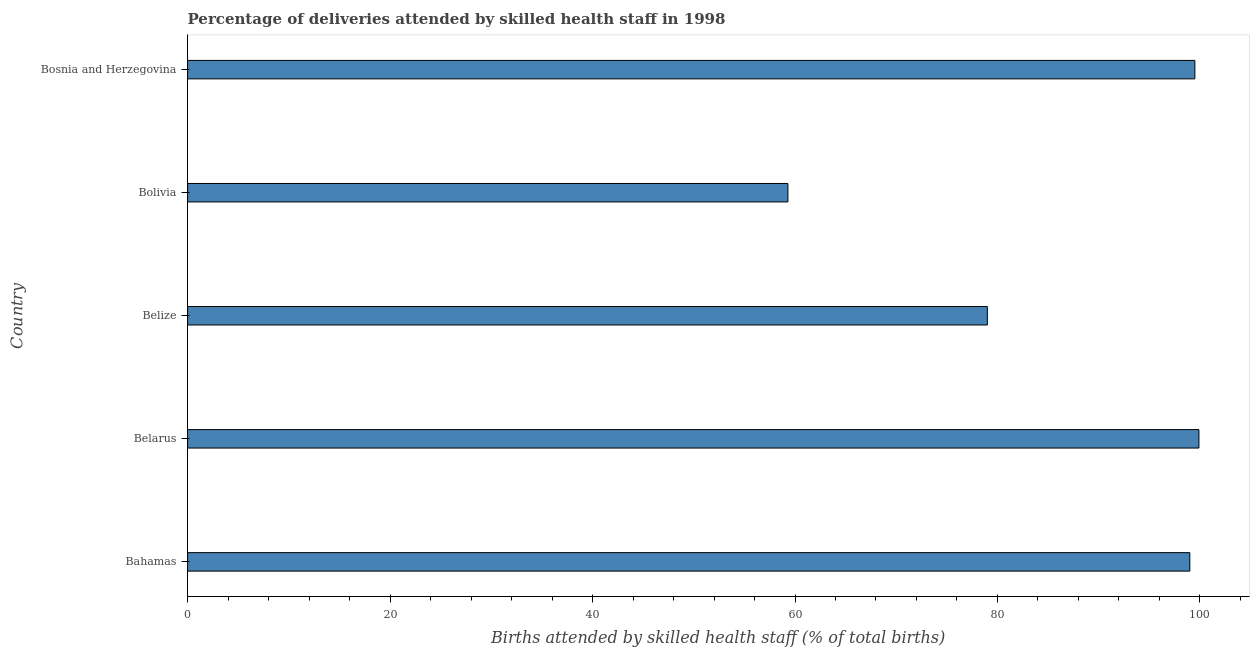Does the graph contain any zero values?
Keep it short and to the point. No. Does the graph contain grids?
Ensure brevity in your answer.  No. What is the title of the graph?
Your answer should be compact. Percentage of deliveries attended by skilled health staff in 1998. What is the label or title of the X-axis?
Give a very brief answer. Births attended by skilled health staff (% of total births). What is the label or title of the Y-axis?
Give a very brief answer. Country. What is the number of births attended by skilled health staff in Belarus?
Provide a succinct answer. 99.9. Across all countries, what is the maximum number of births attended by skilled health staff?
Offer a terse response. 99.9. Across all countries, what is the minimum number of births attended by skilled health staff?
Your response must be concise. 59.3. In which country was the number of births attended by skilled health staff maximum?
Offer a very short reply. Belarus. In which country was the number of births attended by skilled health staff minimum?
Ensure brevity in your answer.  Bolivia. What is the sum of the number of births attended by skilled health staff?
Ensure brevity in your answer.  436.7. What is the difference between the number of births attended by skilled health staff in Belize and Bolivia?
Ensure brevity in your answer.  19.7. What is the average number of births attended by skilled health staff per country?
Your response must be concise. 87.34. What is the median number of births attended by skilled health staff?
Ensure brevity in your answer.  99. What is the ratio of the number of births attended by skilled health staff in Belarus to that in Bosnia and Herzegovina?
Your answer should be compact. 1. Is the difference between the number of births attended by skilled health staff in Bolivia and Bosnia and Herzegovina greater than the difference between any two countries?
Provide a succinct answer. No. What is the difference between the highest and the second highest number of births attended by skilled health staff?
Ensure brevity in your answer.  0.4. What is the difference between the highest and the lowest number of births attended by skilled health staff?
Your answer should be very brief. 40.6. How many countries are there in the graph?
Your answer should be compact. 5. What is the Births attended by skilled health staff (% of total births) in Belarus?
Ensure brevity in your answer.  99.9. What is the Births attended by skilled health staff (% of total births) of Belize?
Offer a terse response. 79. What is the Births attended by skilled health staff (% of total births) of Bolivia?
Provide a succinct answer. 59.3. What is the Births attended by skilled health staff (% of total births) of Bosnia and Herzegovina?
Provide a succinct answer. 99.5. What is the difference between the Births attended by skilled health staff (% of total births) in Bahamas and Bolivia?
Ensure brevity in your answer.  39.7. What is the difference between the Births attended by skilled health staff (% of total births) in Bahamas and Bosnia and Herzegovina?
Your response must be concise. -0.5. What is the difference between the Births attended by skilled health staff (% of total births) in Belarus and Belize?
Ensure brevity in your answer.  20.9. What is the difference between the Births attended by skilled health staff (% of total births) in Belarus and Bolivia?
Ensure brevity in your answer.  40.6. What is the difference between the Births attended by skilled health staff (% of total births) in Belize and Bosnia and Herzegovina?
Provide a succinct answer. -20.5. What is the difference between the Births attended by skilled health staff (% of total births) in Bolivia and Bosnia and Herzegovina?
Your answer should be very brief. -40.2. What is the ratio of the Births attended by skilled health staff (% of total births) in Bahamas to that in Belize?
Offer a very short reply. 1.25. What is the ratio of the Births attended by skilled health staff (% of total births) in Bahamas to that in Bolivia?
Offer a very short reply. 1.67. What is the ratio of the Births attended by skilled health staff (% of total births) in Belarus to that in Belize?
Offer a terse response. 1.26. What is the ratio of the Births attended by skilled health staff (% of total births) in Belarus to that in Bolivia?
Provide a short and direct response. 1.69. What is the ratio of the Births attended by skilled health staff (% of total births) in Belarus to that in Bosnia and Herzegovina?
Your answer should be very brief. 1. What is the ratio of the Births attended by skilled health staff (% of total births) in Belize to that in Bolivia?
Provide a short and direct response. 1.33. What is the ratio of the Births attended by skilled health staff (% of total births) in Belize to that in Bosnia and Herzegovina?
Your answer should be very brief. 0.79. What is the ratio of the Births attended by skilled health staff (% of total births) in Bolivia to that in Bosnia and Herzegovina?
Your answer should be compact. 0.6. 